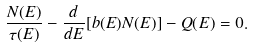Convert formula to latex. <formula><loc_0><loc_0><loc_500><loc_500>\frac { N ( E ) } { \tau ( E ) } - \frac { d } { d E } [ b ( E ) N ( E ) ] - Q ( E ) = 0 .</formula> 